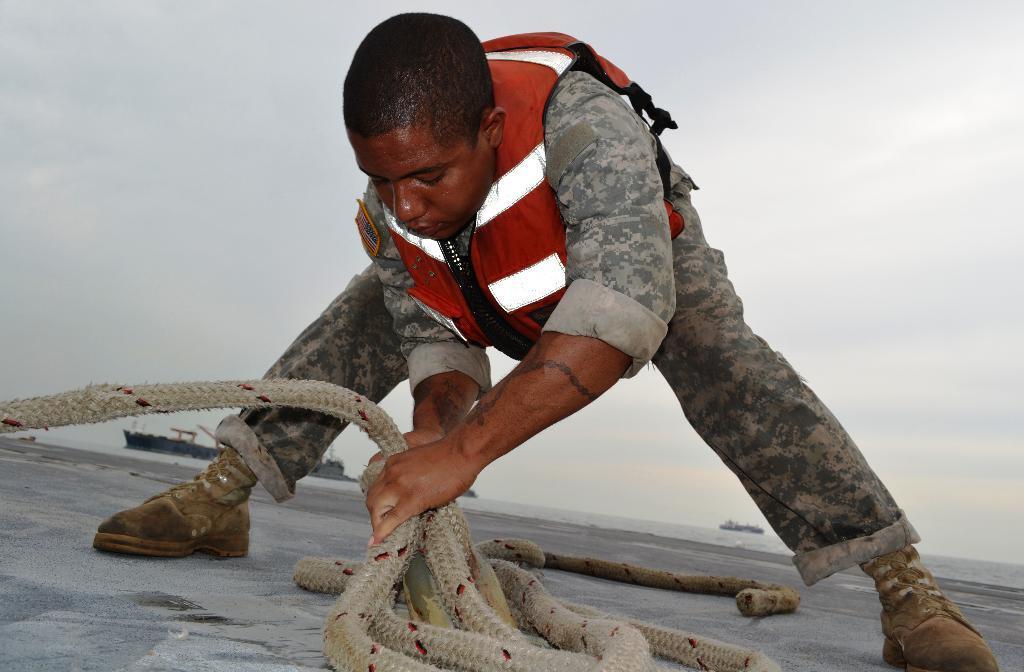Can you describe this image briefly? In the middle of the image a person is standing and holding a rope. Behind him there are some clouds in the sky. 